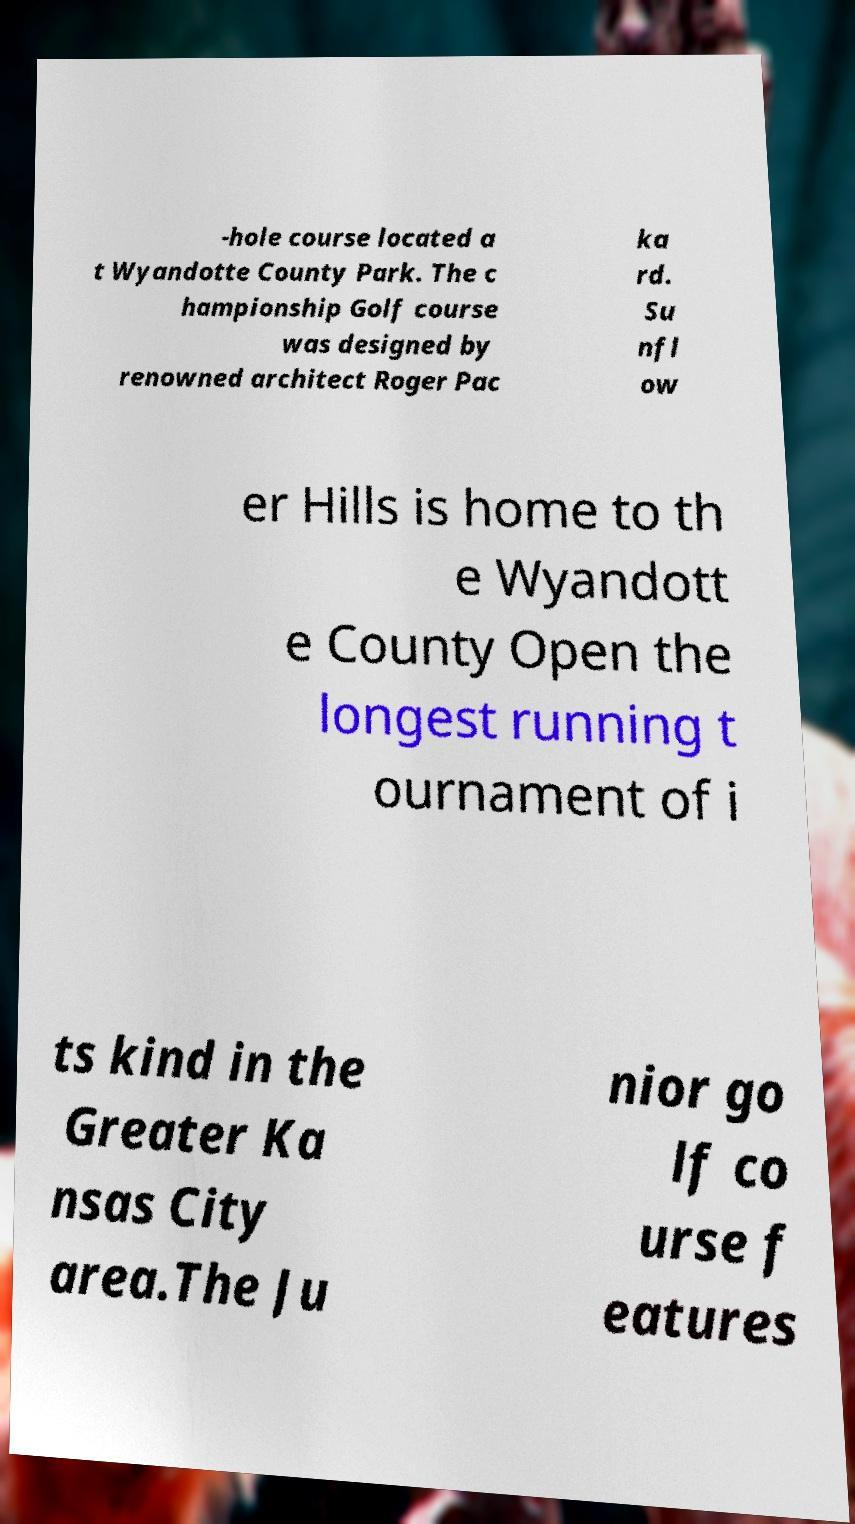Please identify and transcribe the text found in this image. -hole course located a t Wyandotte County Park. The c hampionship Golf course was designed by renowned architect Roger Pac ka rd. Su nfl ow er Hills is home to th e Wyandott e County Open the longest running t ournament of i ts kind in the Greater Ka nsas City area.The Ju nior go lf co urse f eatures 